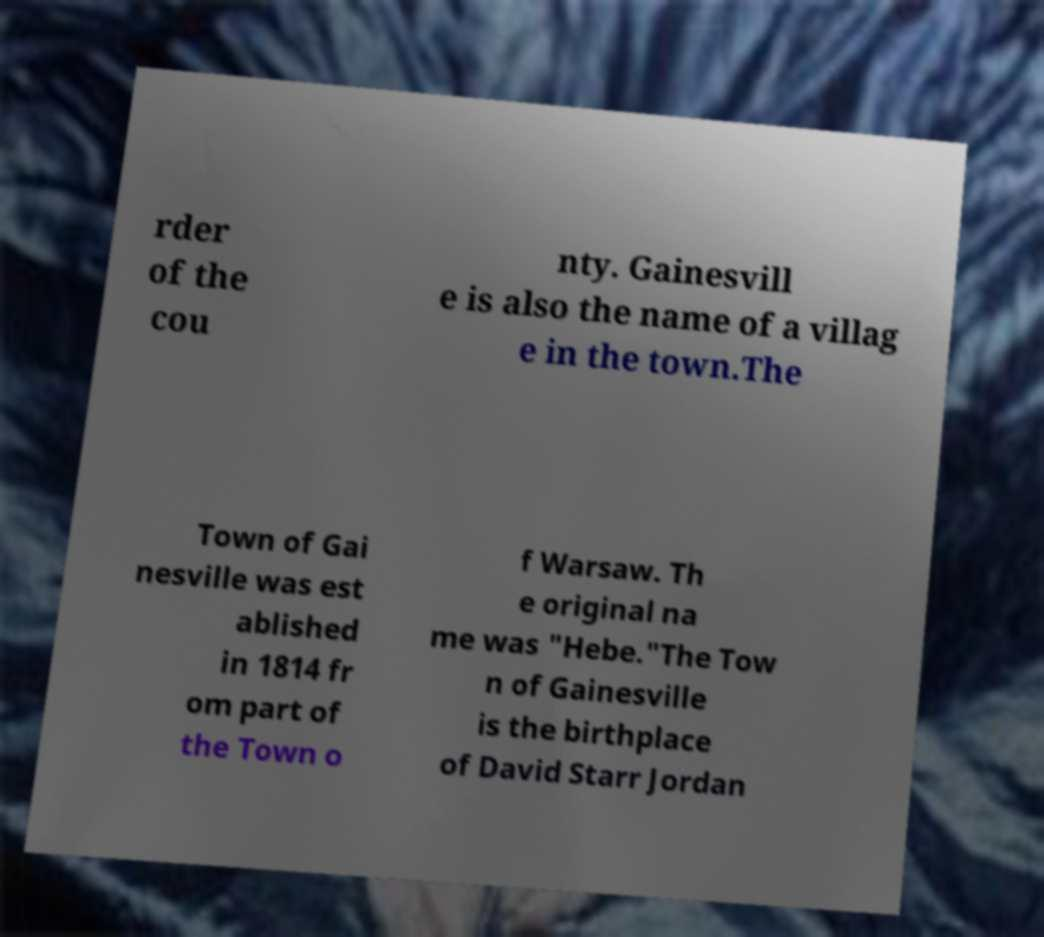Please identify and transcribe the text found in this image. rder of the cou nty. Gainesvill e is also the name of a villag e in the town.The Town of Gai nesville was est ablished in 1814 fr om part of the Town o f Warsaw. Th e original na me was "Hebe."The Tow n of Gainesville is the birthplace of David Starr Jordan 